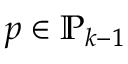<formula> <loc_0><loc_0><loc_500><loc_500>p \in \mathbb { P } _ { k - 1 }</formula> 